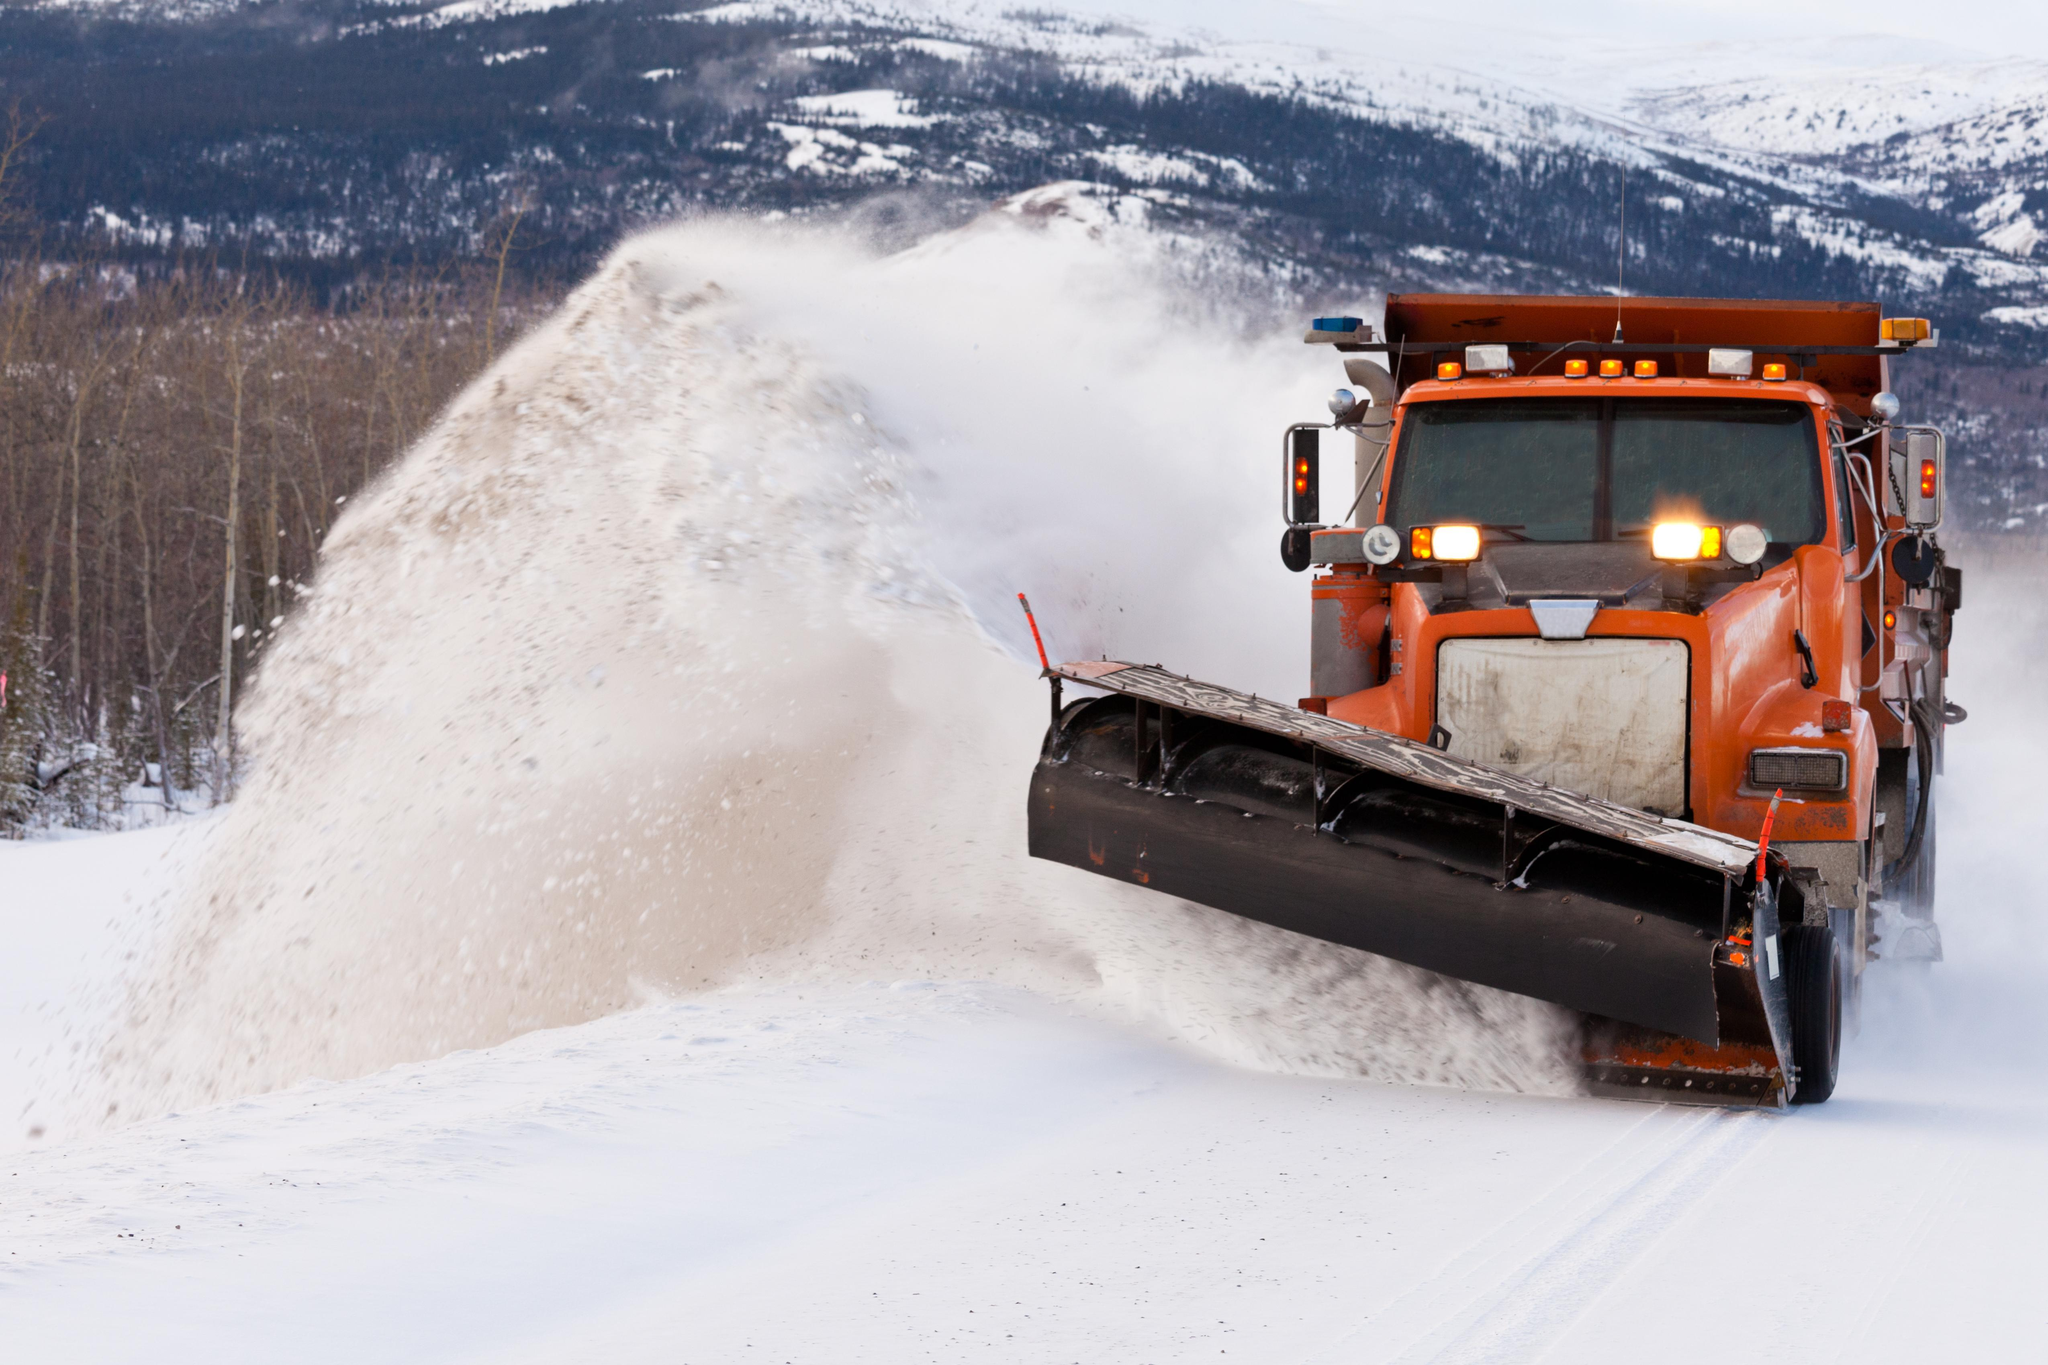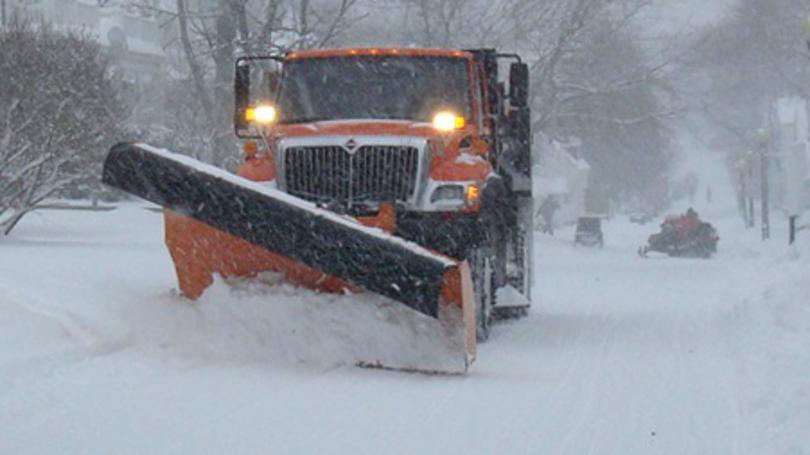The first image is the image on the left, the second image is the image on the right. Considering the images on both sides, is "At least one of the vehicles has its shovel tilted with the left side higher than the right" valid? Answer yes or no. Yes. The first image is the image on the left, the second image is the image on the right. Given the left and right images, does the statement "The left and right image contains the same number of orange snow trucks." hold true? Answer yes or no. Yes. 